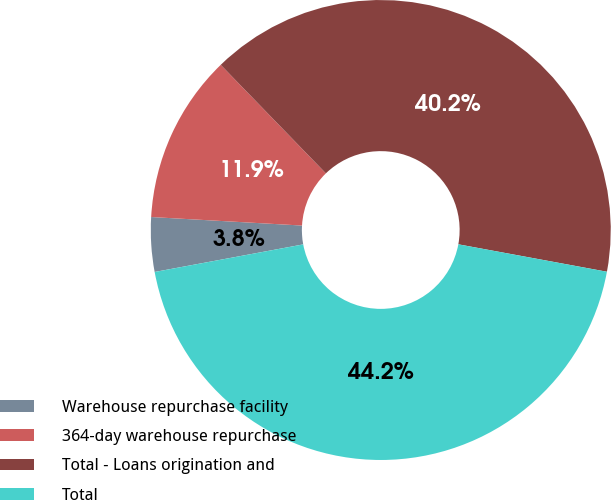<chart> <loc_0><loc_0><loc_500><loc_500><pie_chart><fcel>Warehouse repurchase facility<fcel>364-day warehouse repurchase<fcel>Total - Loans origination and<fcel>Total<nl><fcel>3.82%<fcel>11.85%<fcel>40.15%<fcel>44.17%<nl></chart> 